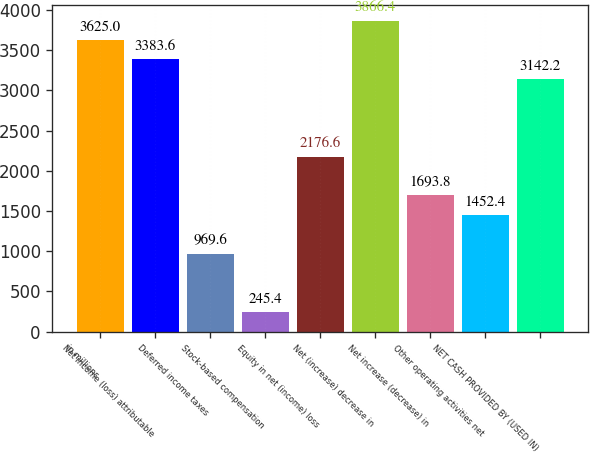Convert chart. <chart><loc_0><loc_0><loc_500><loc_500><bar_chart><fcel>in millions<fcel>Net income (loss) attributable<fcel>Deferred income taxes<fcel>Stock-based compensation<fcel>Equity in net (income) loss<fcel>Net (increase) decrease in<fcel>Net increase (decrease) in<fcel>Other operating activities net<fcel>NET CASH PROVIDED BY (USED IN)<nl><fcel>3625<fcel>3383.6<fcel>969.6<fcel>245.4<fcel>2176.6<fcel>3866.4<fcel>1693.8<fcel>1452.4<fcel>3142.2<nl></chart> 